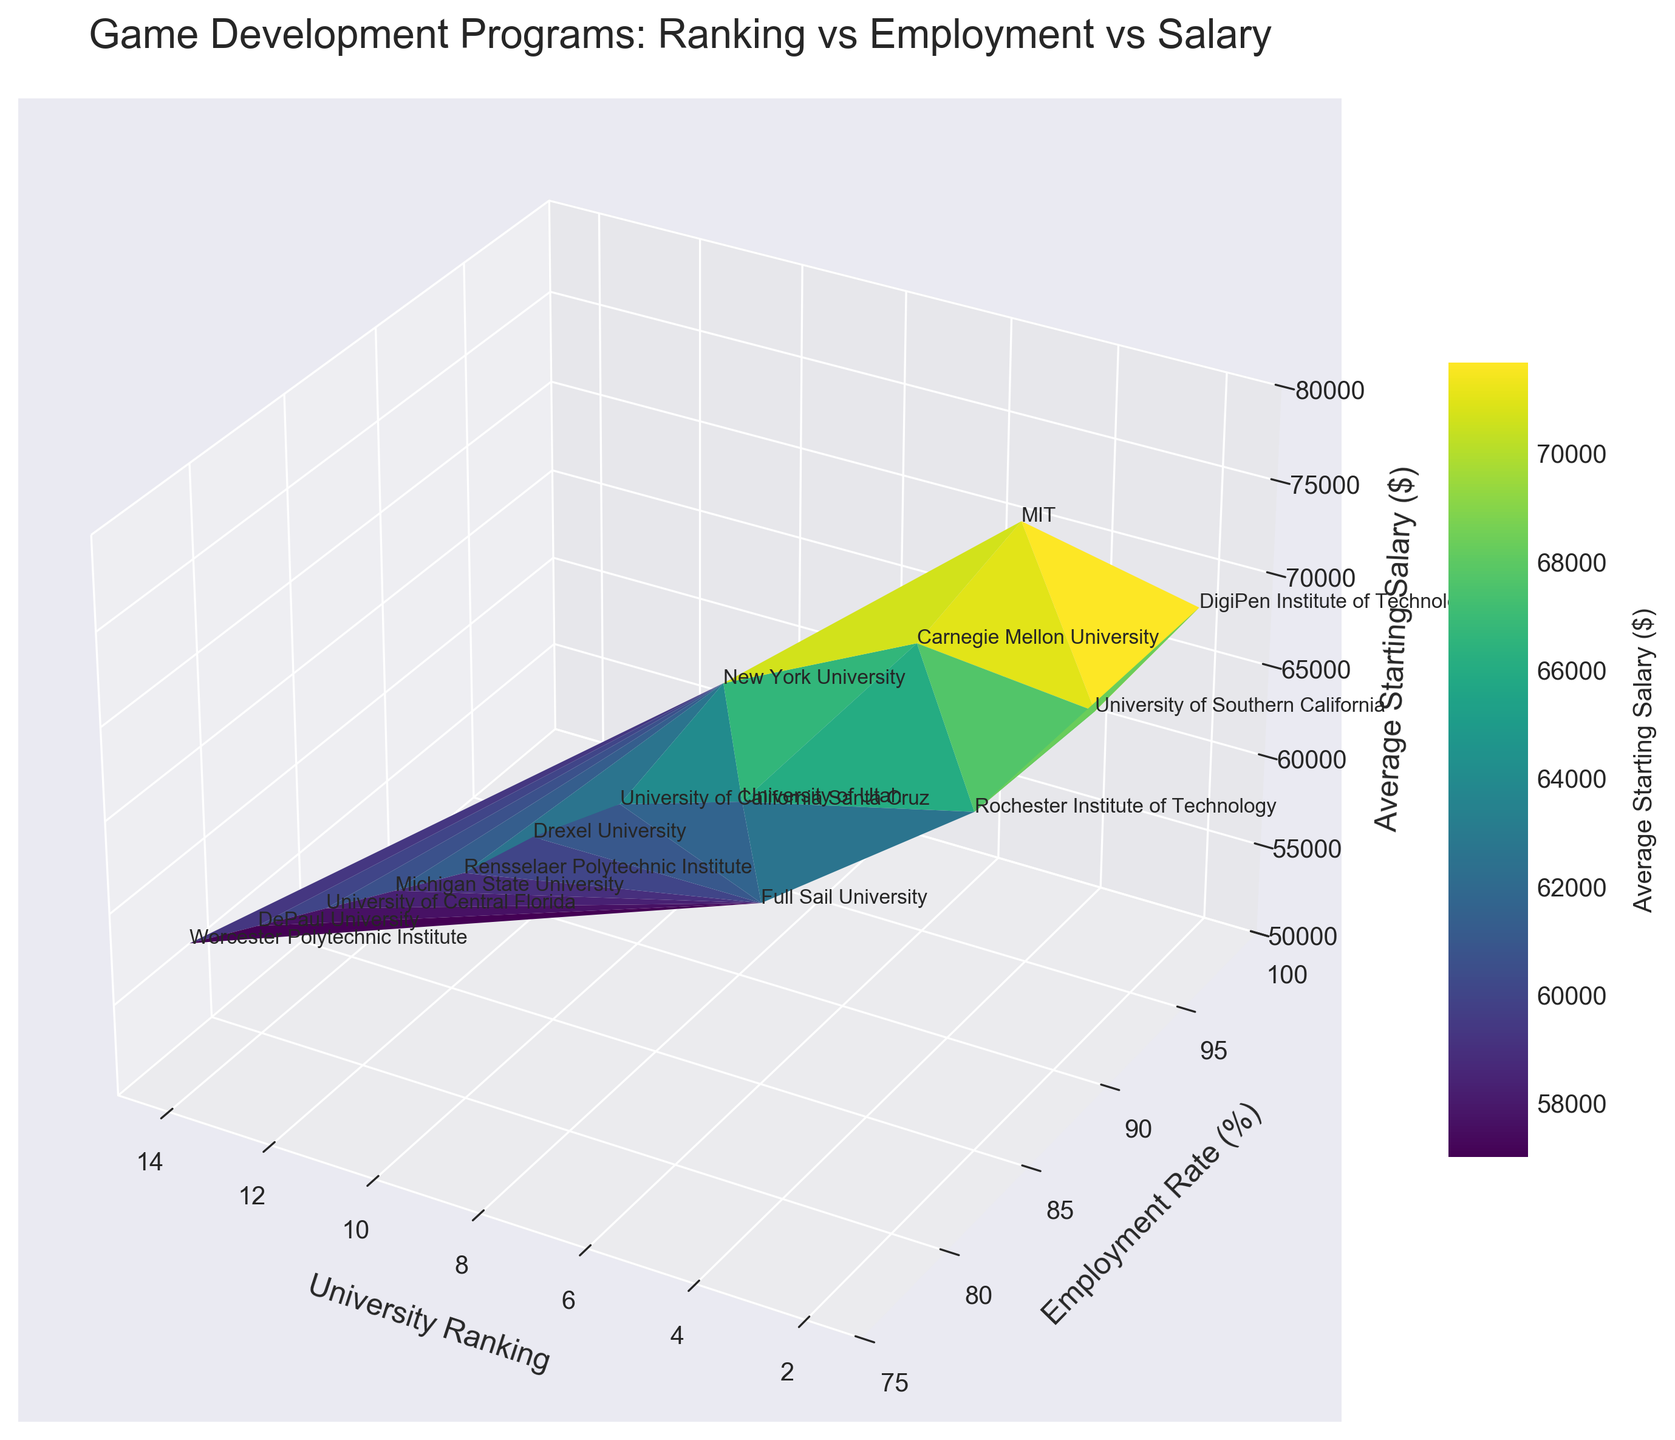What does the 3D surface plot represent? The plot title is "Game Development Programs: Ranking vs Employment vs Salary," indicating that the plot represents the correlation between university game development program rankings, graduate employment rates, and average starting salaries.
Answer: The correlation between university game development program rankings, graduate employment rates, and average starting salaries How is the average starting salary color-coded in the plot? The color of the surface on the plot changes based on the average starting salary, with different shades representing different salary values. This is specified by the color bar labeled 'Average Starting Salary ($).'
Answer: Different shades representing different salary values Which university has the highest employment rate? By examining the Y-axis labeled 'Employment Rate (%),' the university with the highest employment rate appears at the top. In this plot, DigiPen Institute of Technology, with a ranking of 1, has the highest employment rate.
Answer: DigiPen Institute of Technology How does the employment rate change with the university ranking? Looking at the plot, there is a general trend where higher-ranked universities (lower numerical ranking) have higher employment rates. The employment rate tends to decrease as the ranking number increases.
Answer: Higher-ranked universities have higher employment rates Which university has the highest average starting salary? By referring to the Z-axis labeled 'Average Starting Salary ($),' the university with the highest point on this axis has the highest average salary. MIT has the highest average starting salary.
Answer: MIT How does the average starting salary correlate with the employment rate for high-ranked universities? High-ranked universities (lower ranking numbers) on the plot tend to have both high employment rates and high average starting salaries. This is evident from the clustering of data points with high Z and Y values towards the low end of the X-axis.
Answer: High employment rates and high average starting salaries Which university has a lower employment rate but a relatively high average starting salary? The university with a lower placement on the Y-axis (employment rate) but a higher placement on the Z-axis (average starting salary) needs to be identified. Carnegie Mellon University, ranked 5th, fits this description with a good salary but lower employment rate compared to the top-ranked universities.
Answer: Carnegie Mellon University What is the range of employment rates observed in the plot? By examining the Y-axis labeled 'Employment Rate (%),' we can see that the employment rates range from 79% to 95%.
Answer: 79% to 95% Are there any universities with similar average starting salaries but different employment rates? By looking for points on the Z-axis (average salary) that are roughly at the same height but have different placements on the Y-axis (employment rate), we can identify such universities. As an example, New York University and University of Southern California have similar starting salaries but different employment rates.
Answer: New York University and University of Southern California Which university ranks highest and has the total highest combination of employment rate and average starting salary? To determine the highest total combination of employment rate and starting salary, we sum the Y-axis and Z-axis values for each university and find the maximum. DigiPen Institute of Technology has the highest combination with 95% employment rate and $72,000 average starting salary.
Answer: DigiPen Institute of Technology 